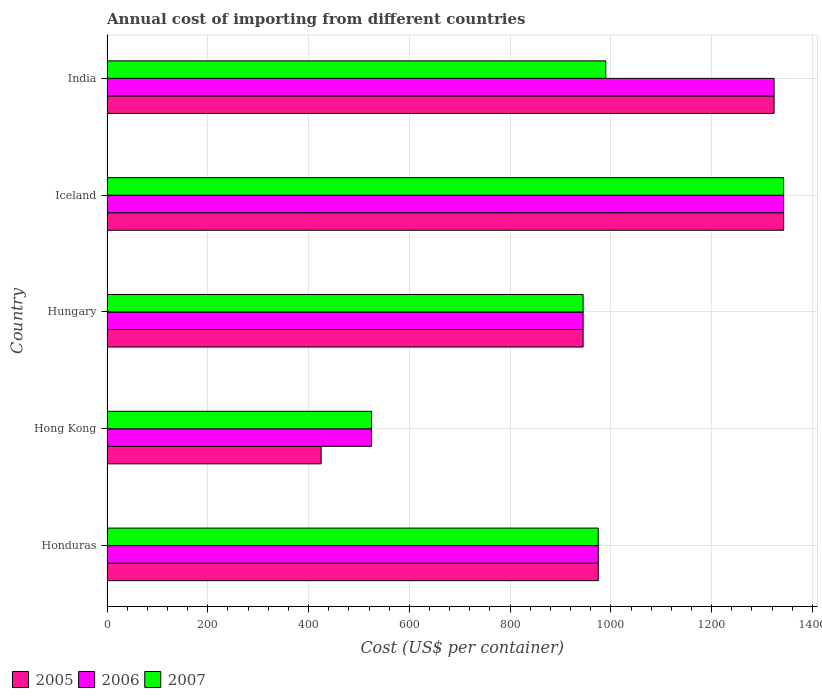How many different coloured bars are there?
Your response must be concise. 3. How many groups of bars are there?
Make the answer very short. 5. Are the number of bars per tick equal to the number of legend labels?
Give a very brief answer. Yes. How many bars are there on the 2nd tick from the top?
Ensure brevity in your answer.  3. In how many cases, is the number of bars for a given country not equal to the number of legend labels?
Provide a short and direct response. 0. What is the total annual cost of importing in 2006 in Hong Kong?
Your answer should be very brief. 525. Across all countries, what is the maximum total annual cost of importing in 2006?
Offer a very short reply. 1343. Across all countries, what is the minimum total annual cost of importing in 2005?
Your response must be concise. 425. In which country was the total annual cost of importing in 2006 maximum?
Provide a short and direct response. Iceland. In which country was the total annual cost of importing in 2006 minimum?
Your answer should be compact. Hong Kong. What is the total total annual cost of importing in 2007 in the graph?
Your answer should be compact. 4778. What is the difference between the total annual cost of importing in 2006 in Hungary and that in Iceland?
Offer a very short reply. -398. What is the average total annual cost of importing in 2005 per country?
Your answer should be very brief. 1002.4. What is the ratio of the total annual cost of importing in 2007 in Hungary to that in Iceland?
Ensure brevity in your answer.  0.7. Is the total annual cost of importing in 2005 in Hong Kong less than that in Hungary?
Ensure brevity in your answer.  Yes. Is the difference between the total annual cost of importing in 2007 in Honduras and Iceland greater than the difference between the total annual cost of importing in 2005 in Honduras and Iceland?
Provide a succinct answer. No. What is the difference between the highest and the second highest total annual cost of importing in 2005?
Offer a terse response. 19. What is the difference between the highest and the lowest total annual cost of importing in 2007?
Offer a terse response. 818. What does the 1st bar from the top in Iceland represents?
Provide a short and direct response. 2007. What does the 3rd bar from the bottom in Honduras represents?
Ensure brevity in your answer.  2007. How many bars are there?
Your answer should be compact. 15. Are all the bars in the graph horizontal?
Offer a terse response. Yes. Are the values on the major ticks of X-axis written in scientific E-notation?
Ensure brevity in your answer.  No. Does the graph contain grids?
Your response must be concise. Yes. How many legend labels are there?
Provide a short and direct response. 3. What is the title of the graph?
Ensure brevity in your answer.  Annual cost of importing from different countries. What is the label or title of the X-axis?
Give a very brief answer. Cost (US$ per container). What is the label or title of the Y-axis?
Give a very brief answer. Country. What is the Cost (US$ per container) of 2005 in Honduras?
Provide a succinct answer. 975. What is the Cost (US$ per container) in 2006 in Honduras?
Your answer should be very brief. 975. What is the Cost (US$ per container) of 2007 in Honduras?
Offer a very short reply. 975. What is the Cost (US$ per container) in 2005 in Hong Kong?
Your answer should be very brief. 425. What is the Cost (US$ per container) in 2006 in Hong Kong?
Offer a very short reply. 525. What is the Cost (US$ per container) of 2007 in Hong Kong?
Offer a terse response. 525. What is the Cost (US$ per container) of 2005 in Hungary?
Ensure brevity in your answer.  945. What is the Cost (US$ per container) of 2006 in Hungary?
Ensure brevity in your answer.  945. What is the Cost (US$ per container) in 2007 in Hungary?
Offer a terse response. 945. What is the Cost (US$ per container) of 2005 in Iceland?
Offer a terse response. 1343. What is the Cost (US$ per container) of 2006 in Iceland?
Your answer should be very brief. 1343. What is the Cost (US$ per container) of 2007 in Iceland?
Your answer should be compact. 1343. What is the Cost (US$ per container) of 2005 in India?
Offer a terse response. 1324. What is the Cost (US$ per container) of 2006 in India?
Provide a succinct answer. 1324. What is the Cost (US$ per container) in 2007 in India?
Your answer should be very brief. 990. Across all countries, what is the maximum Cost (US$ per container) of 2005?
Make the answer very short. 1343. Across all countries, what is the maximum Cost (US$ per container) of 2006?
Provide a succinct answer. 1343. Across all countries, what is the maximum Cost (US$ per container) in 2007?
Keep it short and to the point. 1343. Across all countries, what is the minimum Cost (US$ per container) of 2005?
Provide a short and direct response. 425. Across all countries, what is the minimum Cost (US$ per container) in 2006?
Provide a short and direct response. 525. Across all countries, what is the minimum Cost (US$ per container) of 2007?
Your answer should be very brief. 525. What is the total Cost (US$ per container) in 2005 in the graph?
Provide a succinct answer. 5012. What is the total Cost (US$ per container) of 2006 in the graph?
Your answer should be compact. 5112. What is the total Cost (US$ per container) in 2007 in the graph?
Give a very brief answer. 4778. What is the difference between the Cost (US$ per container) of 2005 in Honduras and that in Hong Kong?
Ensure brevity in your answer.  550. What is the difference between the Cost (US$ per container) of 2006 in Honduras and that in Hong Kong?
Your response must be concise. 450. What is the difference between the Cost (US$ per container) of 2007 in Honduras and that in Hong Kong?
Provide a short and direct response. 450. What is the difference between the Cost (US$ per container) in 2005 in Honduras and that in Iceland?
Keep it short and to the point. -368. What is the difference between the Cost (US$ per container) in 2006 in Honduras and that in Iceland?
Your answer should be very brief. -368. What is the difference between the Cost (US$ per container) of 2007 in Honduras and that in Iceland?
Your answer should be very brief. -368. What is the difference between the Cost (US$ per container) of 2005 in Honduras and that in India?
Make the answer very short. -349. What is the difference between the Cost (US$ per container) of 2006 in Honduras and that in India?
Provide a short and direct response. -349. What is the difference between the Cost (US$ per container) in 2007 in Honduras and that in India?
Make the answer very short. -15. What is the difference between the Cost (US$ per container) of 2005 in Hong Kong and that in Hungary?
Keep it short and to the point. -520. What is the difference between the Cost (US$ per container) of 2006 in Hong Kong and that in Hungary?
Keep it short and to the point. -420. What is the difference between the Cost (US$ per container) of 2007 in Hong Kong and that in Hungary?
Keep it short and to the point. -420. What is the difference between the Cost (US$ per container) of 2005 in Hong Kong and that in Iceland?
Offer a very short reply. -918. What is the difference between the Cost (US$ per container) of 2006 in Hong Kong and that in Iceland?
Your answer should be compact. -818. What is the difference between the Cost (US$ per container) of 2007 in Hong Kong and that in Iceland?
Keep it short and to the point. -818. What is the difference between the Cost (US$ per container) in 2005 in Hong Kong and that in India?
Ensure brevity in your answer.  -899. What is the difference between the Cost (US$ per container) in 2006 in Hong Kong and that in India?
Your answer should be compact. -799. What is the difference between the Cost (US$ per container) in 2007 in Hong Kong and that in India?
Provide a succinct answer. -465. What is the difference between the Cost (US$ per container) of 2005 in Hungary and that in Iceland?
Provide a succinct answer. -398. What is the difference between the Cost (US$ per container) in 2006 in Hungary and that in Iceland?
Offer a terse response. -398. What is the difference between the Cost (US$ per container) of 2007 in Hungary and that in Iceland?
Make the answer very short. -398. What is the difference between the Cost (US$ per container) of 2005 in Hungary and that in India?
Provide a succinct answer. -379. What is the difference between the Cost (US$ per container) of 2006 in Hungary and that in India?
Provide a short and direct response. -379. What is the difference between the Cost (US$ per container) in 2007 in Hungary and that in India?
Provide a succinct answer. -45. What is the difference between the Cost (US$ per container) in 2007 in Iceland and that in India?
Provide a short and direct response. 353. What is the difference between the Cost (US$ per container) in 2005 in Honduras and the Cost (US$ per container) in 2006 in Hong Kong?
Offer a terse response. 450. What is the difference between the Cost (US$ per container) in 2005 in Honduras and the Cost (US$ per container) in 2007 in Hong Kong?
Your answer should be compact. 450. What is the difference between the Cost (US$ per container) in 2006 in Honduras and the Cost (US$ per container) in 2007 in Hong Kong?
Your answer should be very brief. 450. What is the difference between the Cost (US$ per container) of 2006 in Honduras and the Cost (US$ per container) of 2007 in Hungary?
Your answer should be very brief. 30. What is the difference between the Cost (US$ per container) in 2005 in Honduras and the Cost (US$ per container) in 2006 in Iceland?
Your response must be concise. -368. What is the difference between the Cost (US$ per container) in 2005 in Honduras and the Cost (US$ per container) in 2007 in Iceland?
Make the answer very short. -368. What is the difference between the Cost (US$ per container) of 2006 in Honduras and the Cost (US$ per container) of 2007 in Iceland?
Keep it short and to the point. -368. What is the difference between the Cost (US$ per container) of 2005 in Honduras and the Cost (US$ per container) of 2006 in India?
Keep it short and to the point. -349. What is the difference between the Cost (US$ per container) of 2005 in Honduras and the Cost (US$ per container) of 2007 in India?
Provide a succinct answer. -15. What is the difference between the Cost (US$ per container) in 2005 in Hong Kong and the Cost (US$ per container) in 2006 in Hungary?
Keep it short and to the point. -520. What is the difference between the Cost (US$ per container) of 2005 in Hong Kong and the Cost (US$ per container) of 2007 in Hungary?
Make the answer very short. -520. What is the difference between the Cost (US$ per container) in 2006 in Hong Kong and the Cost (US$ per container) in 2007 in Hungary?
Your response must be concise. -420. What is the difference between the Cost (US$ per container) of 2005 in Hong Kong and the Cost (US$ per container) of 2006 in Iceland?
Make the answer very short. -918. What is the difference between the Cost (US$ per container) in 2005 in Hong Kong and the Cost (US$ per container) in 2007 in Iceland?
Your answer should be compact. -918. What is the difference between the Cost (US$ per container) of 2006 in Hong Kong and the Cost (US$ per container) of 2007 in Iceland?
Ensure brevity in your answer.  -818. What is the difference between the Cost (US$ per container) in 2005 in Hong Kong and the Cost (US$ per container) in 2006 in India?
Give a very brief answer. -899. What is the difference between the Cost (US$ per container) in 2005 in Hong Kong and the Cost (US$ per container) in 2007 in India?
Make the answer very short. -565. What is the difference between the Cost (US$ per container) in 2006 in Hong Kong and the Cost (US$ per container) in 2007 in India?
Your answer should be very brief. -465. What is the difference between the Cost (US$ per container) in 2005 in Hungary and the Cost (US$ per container) in 2006 in Iceland?
Keep it short and to the point. -398. What is the difference between the Cost (US$ per container) in 2005 in Hungary and the Cost (US$ per container) in 2007 in Iceland?
Make the answer very short. -398. What is the difference between the Cost (US$ per container) of 2006 in Hungary and the Cost (US$ per container) of 2007 in Iceland?
Make the answer very short. -398. What is the difference between the Cost (US$ per container) in 2005 in Hungary and the Cost (US$ per container) in 2006 in India?
Give a very brief answer. -379. What is the difference between the Cost (US$ per container) in 2005 in Hungary and the Cost (US$ per container) in 2007 in India?
Provide a short and direct response. -45. What is the difference between the Cost (US$ per container) in 2006 in Hungary and the Cost (US$ per container) in 2007 in India?
Keep it short and to the point. -45. What is the difference between the Cost (US$ per container) of 2005 in Iceland and the Cost (US$ per container) of 2007 in India?
Ensure brevity in your answer.  353. What is the difference between the Cost (US$ per container) in 2006 in Iceland and the Cost (US$ per container) in 2007 in India?
Offer a very short reply. 353. What is the average Cost (US$ per container) of 2005 per country?
Your response must be concise. 1002.4. What is the average Cost (US$ per container) in 2006 per country?
Keep it short and to the point. 1022.4. What is the average Cost (US$ per container) of 2007 per country?
Offer a very short reply. 955.6. What is the difference between the Cost (US$ per container) in 2005 and Cost (US$ per container) in 2006 in Honduras?
Provide a short and direct response. 0. What is the difference between the Cost (US$ per container) in 2005 and Cost (US$ per container) in 2006 in Hong Kong?
Your answer should be compact. -100. What is the difference between the Cost (US$ per container) of 2005 and Cost (US$ per container) of 2007 in Hong Kong?
Make the answer very short. -100. What is the difference between the Cost (US$ per container) in 2006 and Cost (US$ per container) in 2007 in Hong Kong?
Your answer should be very brief. 0. What is the difference between the Cost (US$ per container) in 2005 and Cost (US$ per container) in 2006 in Hungary?
Keep it short and to the point. 0. What is the difference between the Cost (US$ per container) in 2005 and Cost (US$ per container) in 2007 in Hungary?
Your response must be concise. 0. What is the difference between the Cost (US$ per container) of 2006 and Cost (US$ per container) of 2007 in Iceland?
Make the answer very short. 0. What is the difference between the Cost (US$ per container) in 2005 and Cost (US$ per container) in 2006 in India?
Give a very brief answer. 0. What is the difference between the Cost (US$ per container) of 2005 and Cost (US$ per container) of 2007 in India?
Offer a very short reply. 334. What is the difference between the Cost (US$ per container) of 2006 and Cost (US$ per container) of 2007 in India?
Ensure brevity in your answer.  334. What is the ratio of the Cost (US$ per container) in 2005 in Honduras to that in Hong Kong?
Offer a very short reply. 2.29. What is the ratio of the Cost (US$ per container) in 2006 in Honduras to that in Hong Kong?
Offer a terse response. 1.86. What is the ratio of the Cost (US$ per container) in 2007 in Honduras to that in Hong Kong?
Your response must be concise. 1.86. What is the ratio of the Cost (US$ per container) of 2005 in Honduras to that in Hungary?
Keep it short and to the point. 1.03. What is the ratio of the Cost (US$ per container) of 2006 in Honduras to that in Hungary?
Your answer should be very brief. 1.03. What is the ratio of the Cost (US$ per container) in 2007 in Honduras to that in Hungary?
Your answer should be very brief. 1.03. What is the ratio of the Cost (US$ per container) of 2005 in Honduras to that in Iceland?
Your answer should be very brief. 0.73. What is the ratio of the Cost (US$ per container) of 2006 in Honduras to that in Iceland?
Provide a short and direct response. 0.73. What is the ratio of the Cost (US$ per container) in 2007 in Honduras to that in Iceland?
Offer a very short reply. 0.73. What is the ratio of the Cost (US$ per container) in 2005 in Honduras to that in India?
Offer a very short reply. 0.74. What is the ratio of the Cost (US$ per container) of 2006 in Honduras to that in India?
Your answer should be compact. 0.74. What is the ratio of the Cost (US$ per container) of 2005 in Hong Kong to that in Hungary?
Your response must be concise. 0.45. What is the ratio of the Cost (US$ per container) of 2006 in Hong Kong to that in Hungary?
Give a very brief answer. 0.56. What is the ratio of the Cost (US$ per container) of 2007 in Hong Kong to that in Hungary?
Ensure brevity in your answer.  0.56. What is the ratio of the Cost (US$ per container) in 2005 in Hong Kong to that in Iceland?
Make the answer very short. 0.32. What is the ratio of the Cost (US$ per container) in 2006 in Hong Kong to that in Iceland?
Offer a very short reply. 0.39. What is the ratio of the Cost (US$ per container) of 2007 in Hong Kong to that in Iceland?
Ensure brevity in your answer.  0.39. What is the ratio of the Cost (US$ per container) in 2005 in Hong Kong to that in India?
Your answer should be very brief. 0.32. What is the ratio of the Cost (US$ per container) in 2006 in Hong Kong to that in India?
Make the answer very short. 0.4. What is the ratio of the Cost (US$ per container) in 2007 in Hong Kong to that in India?
Ensure brevity in your answer.  0.53. What is the ratio of the Cost (US$ per container) of 2005 in Hungary to that in Iceland?
Offer a very short reply. 0.7. What is the ratio of the Cost (US$ per container) in 2006 in Hungary to that in Iceland?
Offer a very short reply. 0.7. What is the ratio of the Cost (US$ per container) of 2007 in Hungary to that in Iceland?
Provide a short and direct response. 0.7. What is the ratio of the Cost (US$ per container) of 2005 in Hungary to that in India?
Ensure brevity in your answer.  0.71. What is the ratio of the Cost (US$ per container) in 2006 in Hungary to that in India?
Provide a short and direct response. 0.71. What is the ratio of the Cost (US$ per container) of 2007 in Hungary to that in India?
Make the answer very short. 0.95. What is the ratio of the Cost (US$ per container) in 2005 in Iceland to that in India?
Offer a very short reply. 1.01. What is the ratio of the Cost (US$ per container) in 2006 in Iceland to that in India?
Give a very brief answer. 1.01. What is the ratio of the Cost (US$ per container) in 2007 in Iceland to that in India?
Your answer should be very brief. 1.36. What is the difference between the highest and the second highest Cost (US$ per container) of 2005?
Your answer should be compact. 19. What is the difference between the highest and the second highest Cost (US$ per container) of 2007?
Provide a succinct answer. 353. What is the difference between the highest and the lowest Cost (US$ per container) in 2005?
Your answer should be compact. 918. What is the difference between the highest and the lowest Cost (US$ per container) of 2006?
Your answer should be compact. 818. What is the difference between the highest and the lowest Cost (US$ per container) in 2007?
Make the answer very short. 818. 